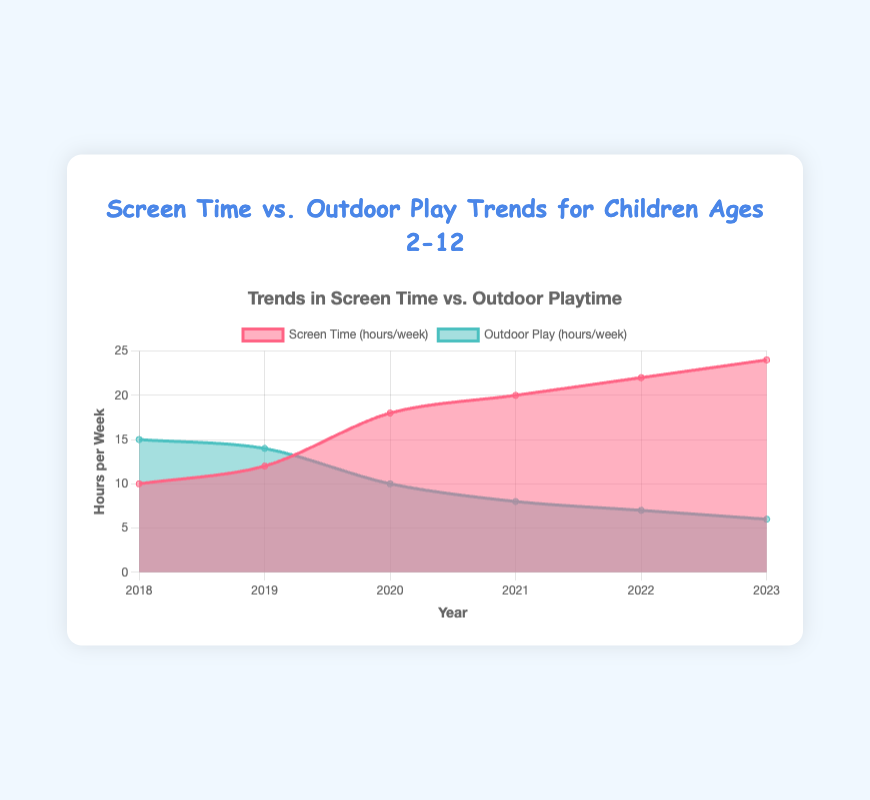what is the title of the chart? The title is displayed at the top of the chart. It reads 'Trends in Screen Time vs. Outdoor Playtime for Children Ages 2-12'.
Answer: Trends in Screen Time vs. Outdoor Playtime for Children Ages 2-12 What colors represent screen time and outdoor play in the chart? The colors are identified by looking at the legend. Screen time is represented by a reddish color, and outdoor play is represented by a teal color.
Answer: Reddish for screen time, tealy for outdoor play Which year had the highest screen time? By checking the values along the 'Screen Time (hours/week)' area, 2023 shows the highest point of 24 hours per week.
Answer: 2023 How much did the outdoor playtime decrease from 2018 to 2023? In 2018, outdoor playtime was 15 hours per week, and in 2023, it was 6 hours per week. The decrease is 15 - 6 = 9 hours per week.
Answer: 9 hours Between which consecutive years was the largest increase in screen time observed? Compare the screen time values between consecutive years: from 2018 to 2019 (2 hours), from 2019 to 2020 (6 hours), from 2020 to 2021 (2 hours), from 2021 to 2022 (2 hours), and from 2022 to 2023 (2 hours). The largest increase, which is 6 hours, was observed from 2019 to 2020.
Answer: 2019 to 2020 In which year was the gap between screen time and outdoor playtime the largest? The gap can be calculated for each year: In 2018, it is 15 - 10 = 5; in 2019, it is 14 - 12 = 2; in 2020, it is 18 - 10 = 8; in 2021, it is 20 - 8 = 12; in 2022, it is 22 - 7 = 15; in 2023, it is 24 - 6 = 18. The largest gap, 18, is in 2023.
Answer: 2023 What was the outdoor playtime trend from 2018 to 2023? Observing the outdoor playtime data points over time: 15, 14, 10, 8, 7, and 6, shows that outdoor playtime was steadily decreasing each year.
Answer: Decreasing How does the overall trend in screen time compare to the trend in outdoor playtime from 2018 to 2023? Screen time shows a continuous increase, whereas outdoor playtime shows a continuous decrease. As years progress from 2018 to 2023, screen time rises from 10 to 24 hours per week while outdoor playtime drops from 15 to 6 hours per week.
Answer: Screen time increasing, outdoor playtime decreasing In which year were screen time and outdoor playtime closest to each other? Check the differences for each year: in 2018, it is 15 - 10 = 5; in 2019, it is 14 - 12 = 2; in 2020, it is 18 - 10 = 8; in 2021, it is 20 - 8 = 12; in 2022, it is 22 - 7 = 15; in 2023, it is 24 - 6 = 18. The smallest difference, which is 2, is in 2019.
Answer: 2019 